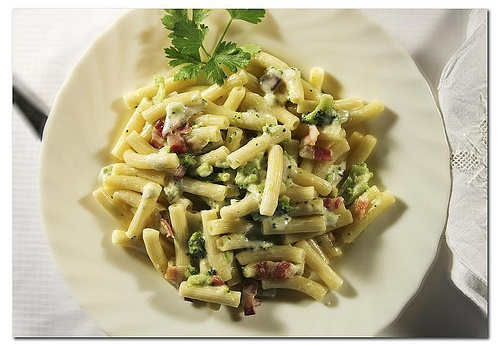Describe the objects in this image and their specific colors. I can see broccoli in white, olive, black, and khaki tones, broccoli in white, darkgreen, black, and olive tones, broccoli in white, black, darkgreen, and olive tones, broccoli in white, darkgreen, black, and olive tones, and broccoli in white, black, olive, darkgreen, and khaki tones in this image. 